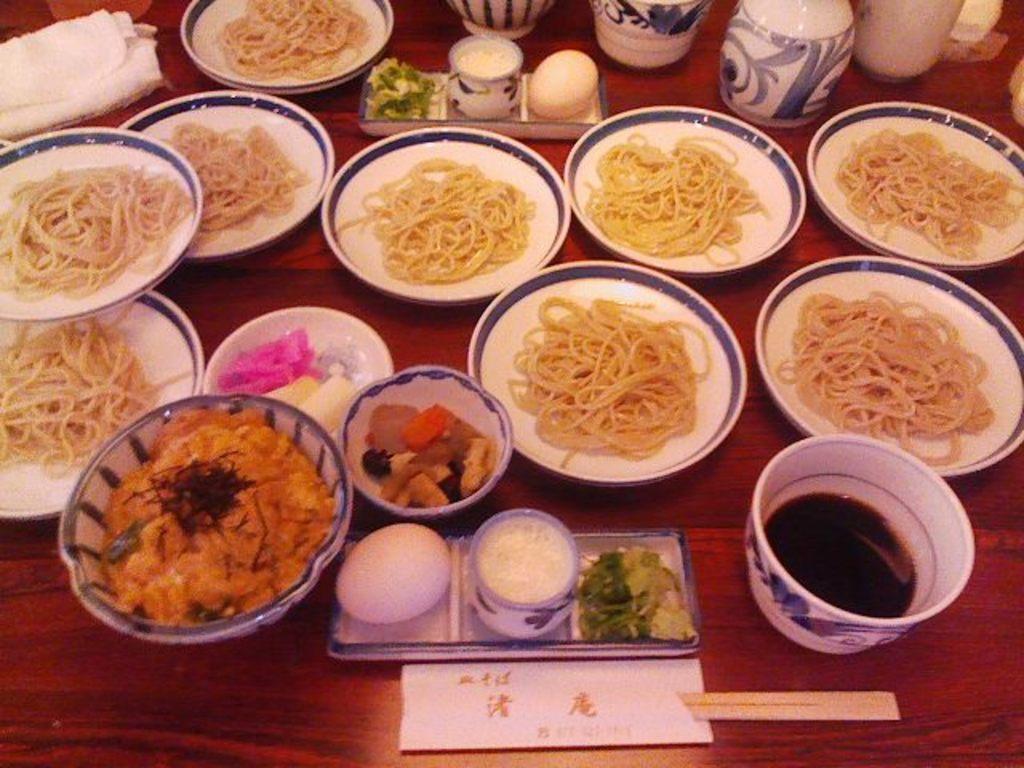Please provide a concise description of this image. In this image, we can see a wooden surface, there are some plates and bowls on the surface, we can see some food on the plates. 